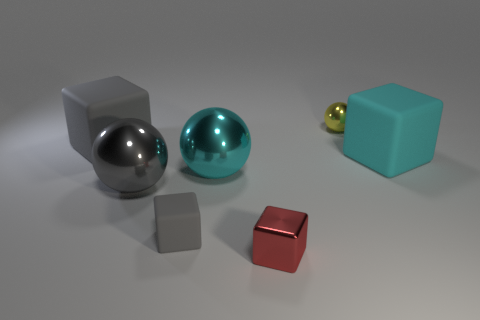There is a cyan thing left of the tiny red metal block; does it have the same size as the cube on the right side of the yellow metal object? yes 